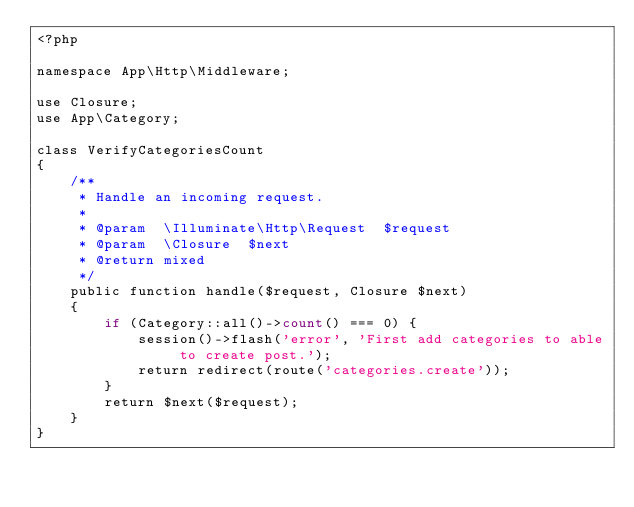Convert code to text. <code><loc_0><loc_0><loc_500><loc_500><_PHP_><?php

namespace App\Http\Middleware;

use Closure;
use App\Category;

class VerifyCategoriesCount
{
    /**
     * Handle an incoming request.
     *
     * @param  \Illuminate\Http\Request  $request
     * @param  \Closure  $next
     * @return mixed
     */
    public function handle($request, Closure $next)
    {
        if (Category::all()->count() === 0) {
            session()->flash('error', 'First add categories to able to create post.');
            return redirect(route('categories.create'));
        }
        return $next($request);
    }
}
</code> 